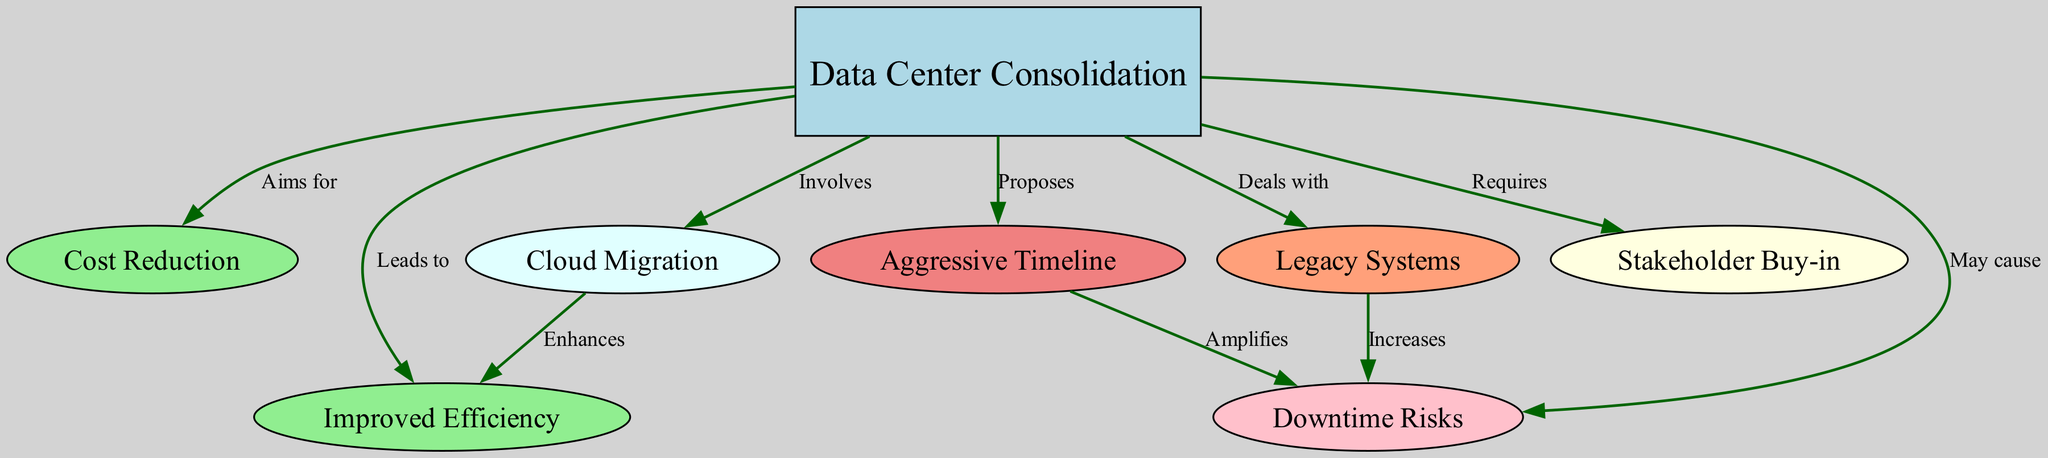What is the central node in the diagram? The central node can be identified by its shape and color, as it is distinctly a box filled with light blue, which indicates that it represents the main concept of the diagram. In this case, the central node is "Data Center Consolidation".
Answer: Data Center Consolidation How many nodes are present in the diagram? To find the total number of nodes, we can count the distinct entries listed under the nodes section in the data provided. There are eight nodes in total.
Answer: 8 What does "Data Center Consolidation" aim for? Looking at the edge that connects to the "Cost Reduction" node, the label "Aims for" indicates that the main aim of data center consolidation is to achieve cost reduction.
Answer: Cost Reduction Which node deals with legacy systems? The node that is specifically connected to the "Data Center Consolidation" node with the label "Deals with" is the "Legacy Systems" node.
Answer: Legacy Systems What does cloud migration enhance? Analyzing the connection from "Cloud Migration" to "Improved Efficiency", the label "Enhances" shows that cloud migration is aimed at enhancing improved efficiency.
Answer: Improved Efficiency What may cause downtime risks? By tracing the edge labeled "May cause", we see that "Data Center Consolidation" can lead to downtime risks, indicating a potential negative outcome of the process.
Answer: Data Center Consolidation What does an aggressive timeline amplify? There is a direct connection from "Aggressive Timeline" to "Downtime Risks" with the label "Amplifies". Thus, an aggressive timeline is known to amplify the risks associated with downtime.
Answer: Downtime Risks What is a requirement for data center consolidation? The edge leading from "Data Center Consolidation" to "Stakeholder Buy-in" indicates that gaining stakeholder buy-in is essential for the consolidation process.
Answer: Stakeholder Buy-in What does the diagram suggest about legacy systems and downtime risks? The edge connecting the "Legacy Systems" node to "Downtime Risks" indicates that legacy systems increase the risk of downtime when consolidating data centers.
Answer: Increases 